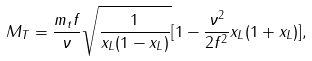Convert formula to latex. <formula><loc_0><loc_0><loc_500><loc_500>M _ { T } = \frac { m _ { t } f } { \nu } \sqrt { \frac { 1 } { x _ { L } ( 1 - x _ { L } ) } } [ 1 - \frac { \nu ^ { 2 } } { 2 f ^ { 2 } } x _ { L } ( 1 + x _ { L } ) ] ,</formula> 